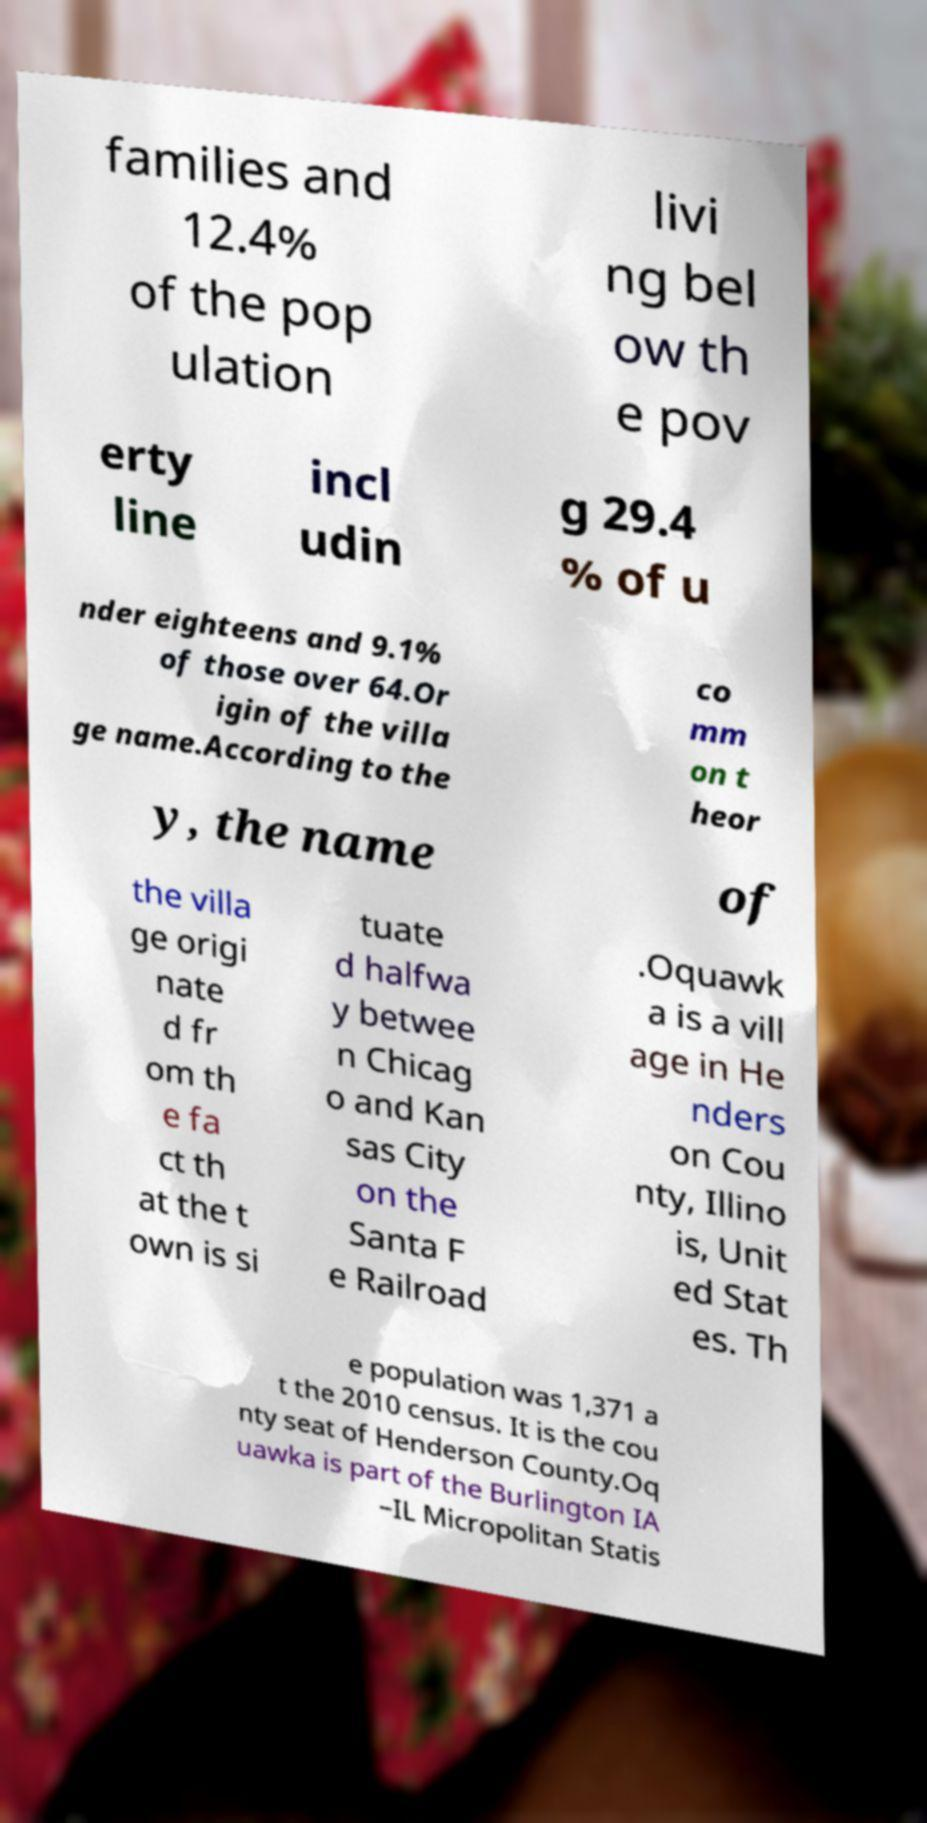I need the written content from this picture converted into text. Can you do that? families and 12.4% of the pop ulation livi ng bel ow th e pov erty line incl udin g 29.4 % of u nder eighteens and 9.1% of those over 64.Or igin of the villa ge name.According to the co mm on t heor y, the name of the villa ge origi nate d fr om th e fa ct th at the t own is si tuate d halfwa y betwee n Chicag o and Kan sas City on the Santa F e Railroad .Oquawk a is a vill age in He nders on Cou nty, Illino is, Unit ed Stat es. Th e population was 1,371 a t the 2010 census. It is the cou nty seat of Henderson County.Oq uawka is part of the Burlington IA –IL Micropolitan Statis 